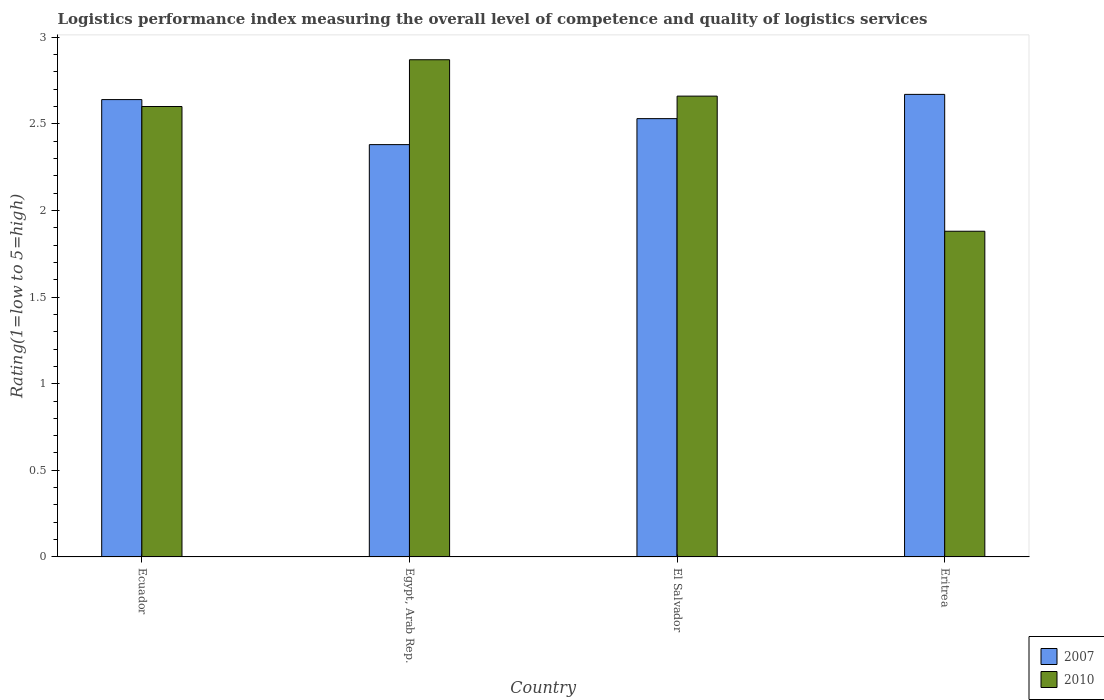How many different coloured bars are there?
Offer a very short reply. 2. How many groups of bars are there?
Your answer should be compact. 4. Are the number of bars per tick equal to the number of legend labels?
Ensure brevity in your answer.  Yes. How many bars are there on the 1st tick from the left?
Offer a terse response. 2. What is the label of the 1st group of bars from the left?
Your answer should be very brief. Ecuador. What is the Logistic performance index in 2010 in Ecuador?
Make the answer very short. 2.6. Across all countries, what is the maximum Logistic performance index in 2010?
Provide a succinct answer. 2.87. Across all countries, what is the minimum Logistic performance index in 2010?
Keep it short and to the point. 1.88. In which country was the Logistic performance index in 2010 maximum?
Offer a terse response. Egypt, Arab Rep. In which country was the Logistic performance index in 2007 minimum?
Offer a very short reply. Egypt, Arab Rep. What is the total Logistic performance index in 2007 in the graph?
Give a very brief answer. 10.22. What is the difference between the Logistic performance index in 2010 in Ecuador and that in El Salvador?
Ensure brevity in your answer.  -0.06. What is the difference between the Logistic performance index in 2010 in Ecuador and the Logistic performance index in 2007 in Egypt, Arab Rep.?
Provide a short and direct response. 0.22. What is the average Logistic performance index in 2007 per country?
Your answer should be compact. 2.55. What is the difference between the Logistic performance index of/in 2007 and Logistic performance index of/in 2010 in Ecuador?
Your answer should be very brief. 0.04. What is the ratio of the Logistic performance index in 2007 in Egypt, Arab Rep. to that in Eritrea?
Provide a short and direct response. 0.89. What is the difference between the highest and the second highest Logistic performance index in 2007?
Provide a succinct answer. 0.03. What is the difference between the highest and the lowest Logistic performance index in 2010?
Offer a very short reply. 0.99. In how many countries, is the Logistic performance index in 2010 greater than the average Logistic performance index in 2010 taken over all countries?
Ensure brevity in your answer.  3. What does the 1st bar from the right in Ecuador represents?
Your response must be concise. 2010. How many countries are there in the graph?
Your answer should be very brief. 4. Does the graph contain grids?
Give a very brief answer. No. What is the title of the graph?
Offer a very short reply. Logistics performance index measuring the overall level of competence and quality of logistics services. Does "1967" appear as one of the legend labels in the graph?
Your response must be concise. No. What is the label or title of the Y-axis?
Your response must be concise. Rating(1=low to 5=high). What is the Rating(1=low to 5=high) of 2007 in Ecuador?
Make the answer very short. 2.64. What is the Rating(1=low to 5=high) in 2010 in Ecuador?
Your response must be concise. 2.6. What is the Rating(1=low to 5=high) of 2007 in Egypt, Arab Rep.?
Offer a very short reply. 2.38. What is the Rating(1=low to 5=high) in 2010 in Egypt, Arab Rep.?
Keep it short and to the point. 2.87. What is the Rating(1=low to 5=high) of 2007 in El Salvador?
Offer a very short reply. 2.53. What is the Rating(1=low to 5=high) of 2010 in El Salvador?
Your answer should be very brief. 2.66. What is the Rating(1=low to 5=high) in 2007 in Eritrea?
Provide a short and direct response. 2.67. What is the Rating(1=low to 5=high) of 2010 in Eritrea?
Keep it short and to the point. 1.88. Across all countries, what is the maximum Rating(1=low to 5=high) in 2007?
Provide a succinct answer. 2.67. Across all countries, what is the maximum Rating(1=low to 5=high) in 2010?
Provide a succinct answer. 2.87. Across all countries, what is the minimum Rating(1=low to 5=high) in 2007?
Offer a very short reply. 2.38. Across all countries, what is the minimum Rating(1=low to 5=high) of 2010?
Provide a succinct answer. 1.88. What is the total Rating(1=low to 5=high) in 2007 in the graph?
Offer a terse response. 10.22. What is the total Rating(1=low to 5=high) of 2010 in the graph?
Give a very brief answer. 10.01. What is the difference between the Rating(1=low to 5=high) in 2007 in Ecuador and that in Egypt, Arab Rep.?
Provide a succinct answer. 0.26. What is the difference between the Rating(1=low to 5=high) of 2010 in Ecuador and that in Egypt, Arab Rep.?
Offer a very short reply. -0.27. What is the difference between the Rating(1=low to 5=high) in 2007 in Ecuador and that in El Salvador?
Offer a very short reply. 0.11. What is the difference between the Rating(1=low to 5=high) of 2010 in Ecuador and that in El Salvador?
Ensure brevity in your answer.  -0.06. What is the difference between the Rating(1=low to 5=high) of 2007 in Ecuador and that in Eritrea?
Your answer should be very brief. -0.03. What is the difference between the Rating(1=low to 5=high) of 2010 in Ecuador and that in Eritrea?
Provide a succinct answer. 0.72. What is the difference between the Rating(1=low to 5=high) in 2007 in Egypt, Arab Rep. and that in El Salvador?
Offer a very short reply. -0.15. What is the difference between the Rating(1=low to 5=high) of 2010 in Egypt, Arab Rep. and that in El Salvador?
Provide a short and direct response. 0.21. What is the difference between the Rating(1=low to 5=high) in 2007 in Egypt, Arab Rep. and that in Eritrea?
Provide a succinct answer. -0.29. What is the difference between the Rating(1=low to 5=high) in 2010 in Egypt, Arab Rep. and that in Eritrea?
Your response must be concise. 0.99. What is the difference between the Rating(1=low to 5=high) in 2007 in El Salvador and that in Eritrea?
Give a very brief answer. -0.14. What is the difference between the Rating(1=low to 5=high) in 2010 in El Salvador and that in Eritrea?
Ensure brevity in your answer.  0.78. What is the difference between the Rating(1=low to 5=high) in 2007 in Ecuador and the Rating(1=low to 5=high) in 2010 in Egypt, Arab Rep.?
Ensure brevity in your answer.  -0.23. What is the difference between the Rating(1=low to 5=high) of 2007 in Ecuador and the Rating(1=low to 5=high) of 2010 in El Salvador?
Keep it short and to the point. -0.02. What is the difference between the Rating(1=low to 5=high) in 2007 in Ecuador and the Rating(1=low to 5=high) in 2010 in Eritrea?
Your answer should be compact. 0.76. What is the difference between the Rating(1=low to 5=high) of 2007 in Egypt, Arab Rep. and the Rating(1=low to 5=high) of 2010 in El Salvador?
Provide a succinct answer. -0.28. What is the difference between the Rating(1=low to 5=high) in 2007 in Egypt, Arab Rep. and the Rating(1=low to 5=high) in 2010 in Eritrea?
Provide a short and direct response. 0.5. What is the difference between the Rating(1=low to 5=high) in 2007 in El Salvador and the Rating(1=low to 5=high) in 2010 in Eritrea?
Your answer should be very brief. 0.65. What is the average Rating(1=low to 5=high) of 2007 per country?
Your answer should be compact. 2.56. What is the average Rating(1=low to 5=high) of 2010 per country?
Offer a terse response. 2.5. What is the difference between the Rating(1=low to 5=high) of 2007 and Rating(1=low to 5=high) of 2010 in Ecuador?
Ensure brevity in your answer.  0.04. What is the difference between the Rating(1=low to 5=high) of 2007 and Rating(1=low to 5=high) of 2010 in Egypt, Arab Rep.?
Offer a very short reply. -0.49. What is the difference between the Rating(1=low to 5=high) of 2007 and Rating(1=low to 5=high) of 2010 in El Salvador?
Your answer should be very brief. -0.13. What is the difference between the Rating(1=low to 5=high) of 2007 and Rating(1=low to 5=high) of 2010 in Eritrea?
Your answer should be compact. 0.79. What is the ratio of the Rating(1=low to 5=high) of 2007 in Ecuador to that in Egypt, Arab Rep.?
Your answer should be compact. 1.11. What is the ratio of the Rating(1=low to 5=high) in 2010 in Ecuador to that in Egypt, Arab Rep.?
Provide a succinct answer. 0.91. What is the ratio of the Rating(1=low to 5=high) in 2007 in Ecuador to that in El Salvador?
Keep it short and to the point. 1.04. What is the ratio of the Rating(1=low to 5=high) in 2010 in Ecuador to that in El Salvador?
Offer a terse response. 0.98. What is the ratio of the Rating(1=low to 5=high) in 2007 in Ecuador to that in Eritrea?
Your response must be concise. 0.99. What is the ratio of the Rating(1=low to 5=high) of 2010 in Ecuador to that in Eritrea?
Keep it short and to the point. 1.38. What is the ratio of the Rating(1=low to 5=high) of 2007 in Egypt, Arab Rep. to that in El Salvador?
Make the answer very short. 0.94. What is the ratio of the Rating(1=low to 5=high) of 2010 in Egypt, Arab Rep. to that in El Salvador?
Ensure brevity in your answer.  1.08. What is the ratio of the Rating(1=low to 5=high) in 2007 in Egypt, Arab Rep. to that in Eritrea?
Provide a succinct answer. 0.89. What is the ratio of the Rating(1=low to 5=high) of 2010 in Egypt, Arab Rep. to that in Eritrea?
Offer a very short reply. 1.53. What is the ratio of the Rating(1=low to 5=high) in 2007 in El Salvador to that in Eritrea?
Provide a succinct answer. 0.95. What is the ratio of the Rating(1=low to 5=high) of 2010 in El Salvador to that in Eritrea?
Offer a terse response. 1.41. What is the difference between the highest and the second highest Rating(1=low to 5=high) in 2010?
Offer a very short reply. 0.21. What is the difference between the highest and the lowest Rating(1=low to 5=high) in 2007?
Ensure brevity in your answer.  0.29. 